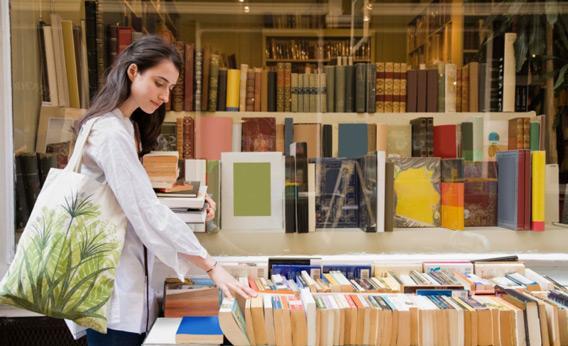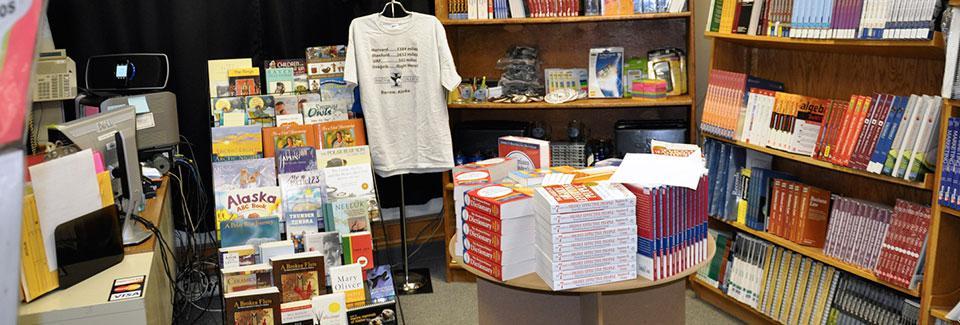The first image is the image on the left, the second image is the image on the right. Given the left and right images, does the statement "A woman in the image on the left has her hand on a rack." hold true? Answer yes or no. Yes. The first image is the image on the left, the second image is the image on the right. Analyze the images presented: Is the assertion "IN at least one image there is only a single woman with long hair browsing the store." valid? Answer yes or no. Yes. 